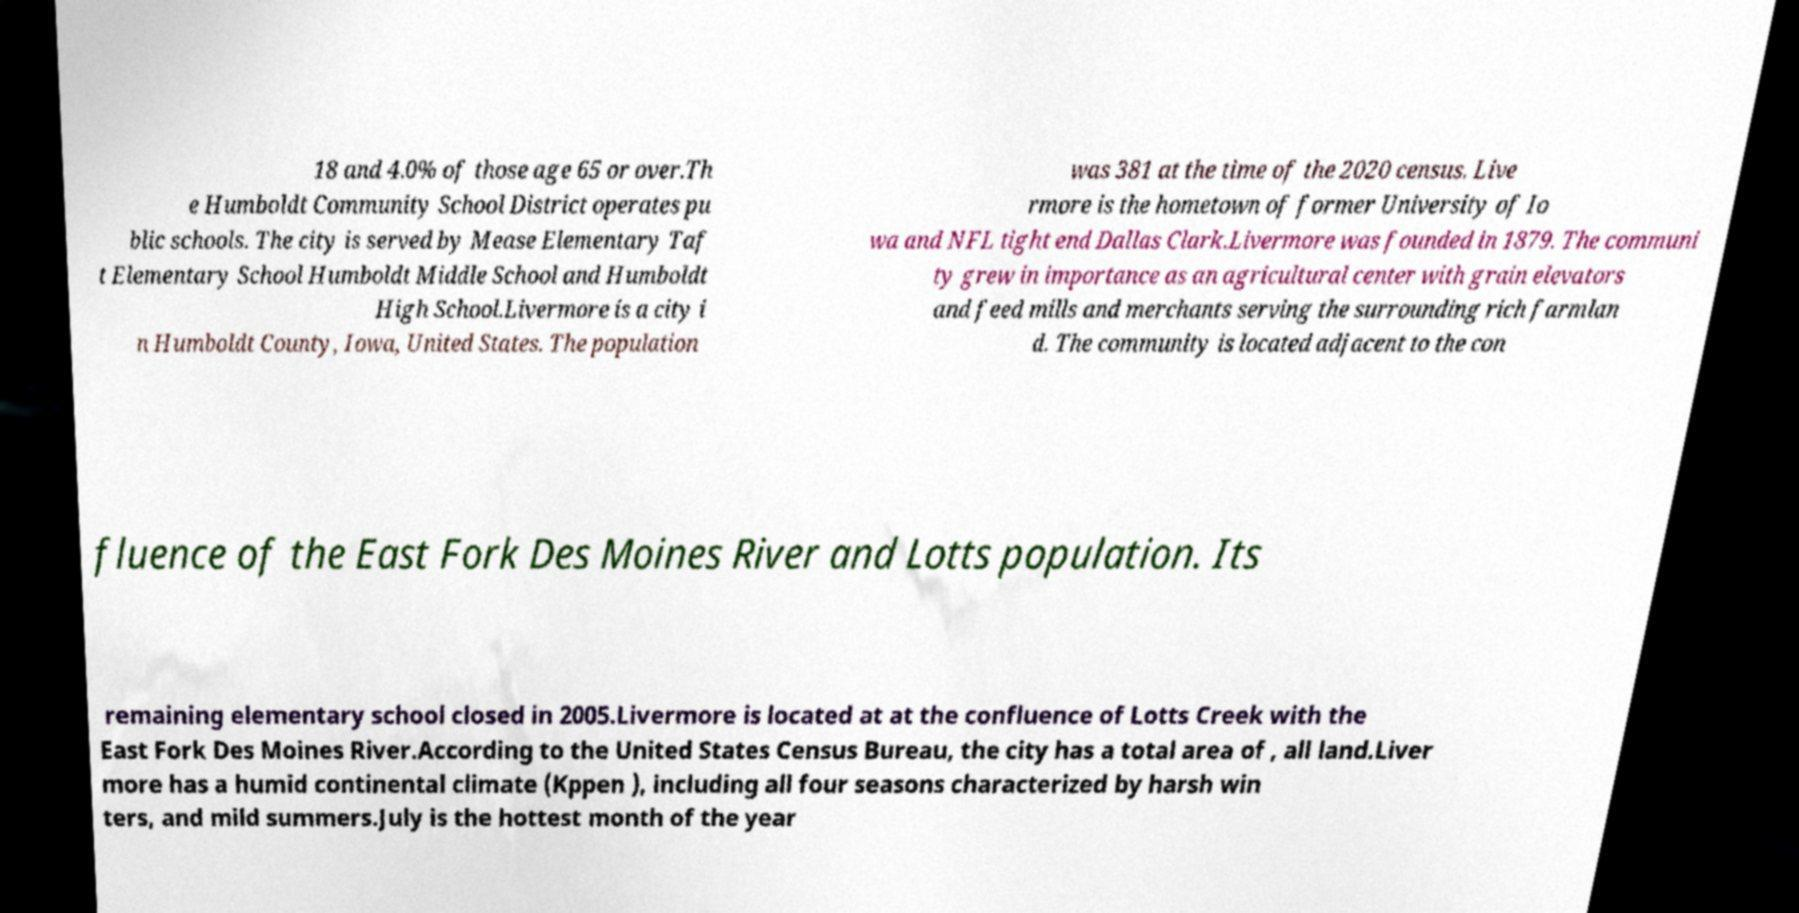Please read and relay the text visible in this image. What does it say? 18 and 4.0% of those age 65 or over.Th e Humboldt Community School District operates pu blic schools. The city is served by Mease Elementary Taf t Elementary School Humboldt Middle School and Humboldt High School.Livermore is a city i n Humboldt County, Iowa, United States. The population was 381 at the time of the 2020 census. Live rmore is the hometown of former University of Io wa and NFL tight end Dallas Clark.Livermore was founded in 1879. The communi ty grew in importance as an agricultural center with grain elevators and feed mills and merchants serving the surrounding rich farmlan d. The community is located adjacent to the con fluence of the East Fork Des Moines River and Lotts population. Its remaining elementary school closed in 2005.Livermore is located at at the confluence of Lotts Creek with the East Fork Des Moines River.According to the United States Census Bureau, the city has a total area of , all land.Liver more has a humid continental climate (Kppen ), including all four seasons characterized by harsh win ters, and mild summers.July is the hottest month of the year 